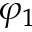Convert formula to latex. <formula><loc_0><loc_0><loc_500><loc_500>\varphi _ { 1 }</formula> 